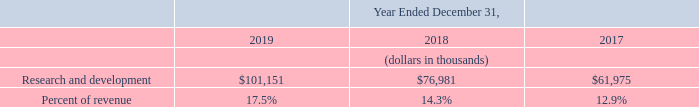Research and Development
Research and development expenses increased $24.2 million, or 31%, in 2019 as compared to 2018. The increase was principally due to the 2018 Reallocation of headcount from sales and marketing to research and development, as well as investments to maintain and improve the functionality of our products. As a result, we incurred increased employee-related costs of $16.3 million and increased overhead costs of $3.4 million.
Research and development expenses increased $15.0 million, or 24%, in 2018 as compared to 2017. The increase was principally due to the 2018 Reallocation of headcount from sales and marketing to research and development, as well as investments to maintain and improve the functionality of our products. As a result, we incurred increased employee-related costs of $12.1 million.
Why did research and development expenses increase between 2018 and 2019? The increase was principally due to the 2018 reallocation of headcount from sales and marketing to research and development, as well as investments. How much were employee-related costs between 2017 and 2018? $12.1 million. What was the percentage of revenue of research and development in 2018? 14.3%. What was the change in percentage of revenue of research and development between 2017 and 2018?
Answer scale should be: percent. (14.3%-12.9%)
Answer: 1.4. What is the average year-on-year increase in Research and development from 2017 to 2019?
Answer scale should be: percent. (($101,151-$76,981)/$76,981+($76,981-$61,975)/$61,975)/2
Answer: 27.81. What was the average research and development from 2017-2019?
Answer scale should be: thousand. ($101,151+$76,981+$61,975)/(2019-2017+1)
Answer: 80035.67. 